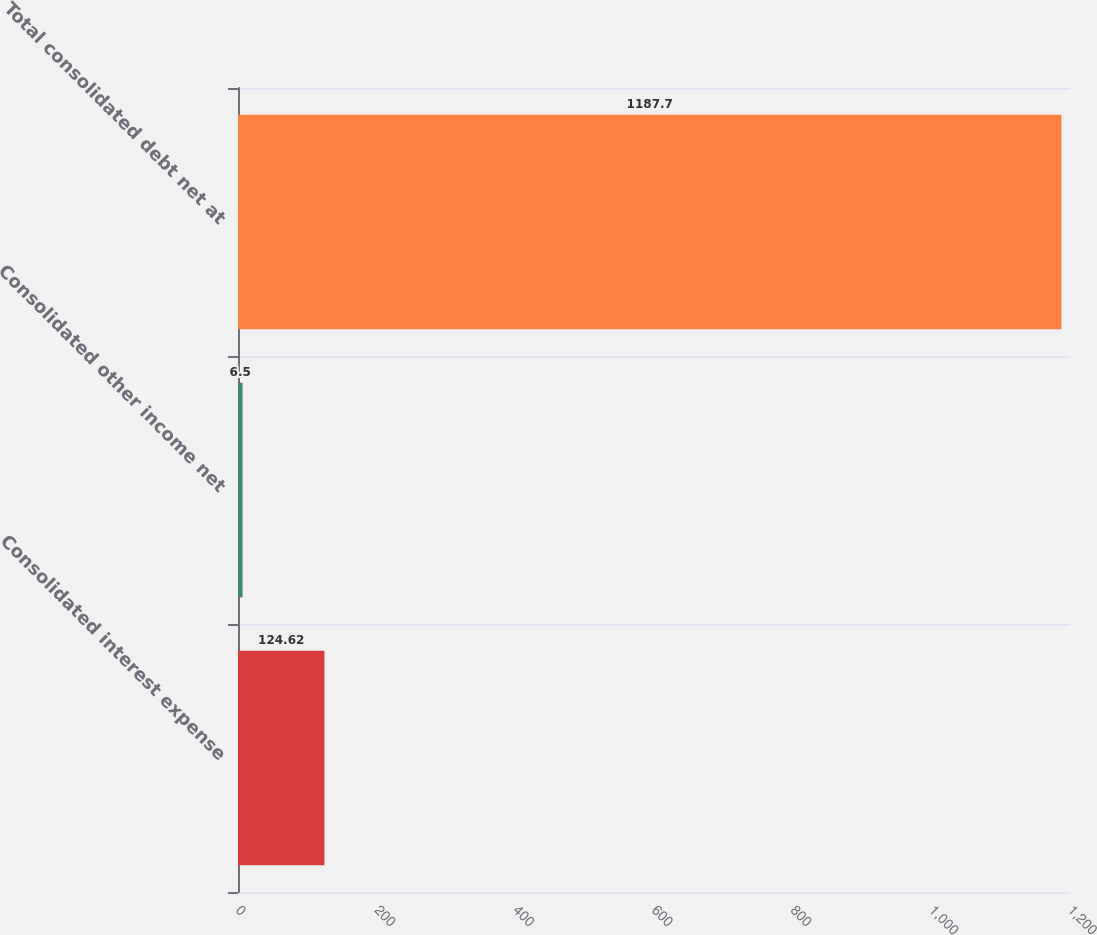Convert chart. <chart><loc_0><loc_0><loc_500><loc_500><bar_chart><fcel>Consolidated interest expense<fcel>Consolidated other income net<fcel>Total consolidated debt net at<nl><fcel>124.62<fcel>6.5<fcel>1187.7<nl></chart> 